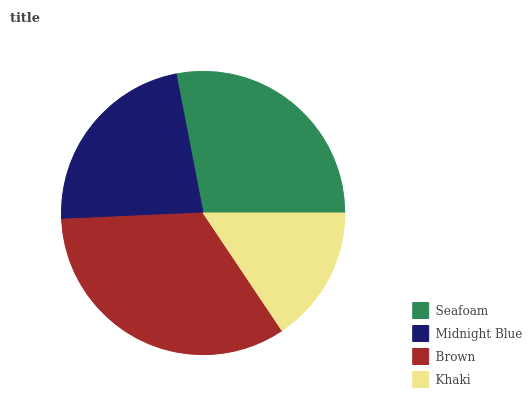Is Khaki the minimum?
Answer yes or no. Yes. Is Brown the maximum?
Answer yes or no. Yes. Is Midnight Blue the minimum?
Answer yes or no. No. Is Midnight Blue the maximum?
Answer yes or no. No. Is Seafoam greater than Midnight Blue?
Answer yes or no. Yes. Is Midnight Blue less than Seafoam?
Answer yes or no. Yes. Is Midnight Blue greater than Seafoam?
Answer yes or no. No. Is Seafoam less than Midnight Blue?
Answer yes or no. No. Is Seafoam the high median?
Answer yes or no. Yes. Is Midnight Blue the low median?
Answer yes or no. Yes. Is Brown the high median?
Answer yes or no. No. Is Khaki the low median?
Answer yes or no. No. 